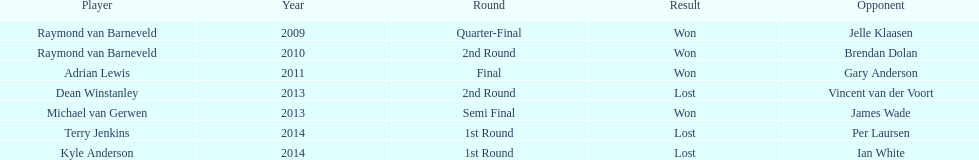Was terry jenkins triumphant in 2014? Terry Jenkins, Lost. If terry jenkins suffered a loss, who claimed the win? Per Laursen. 